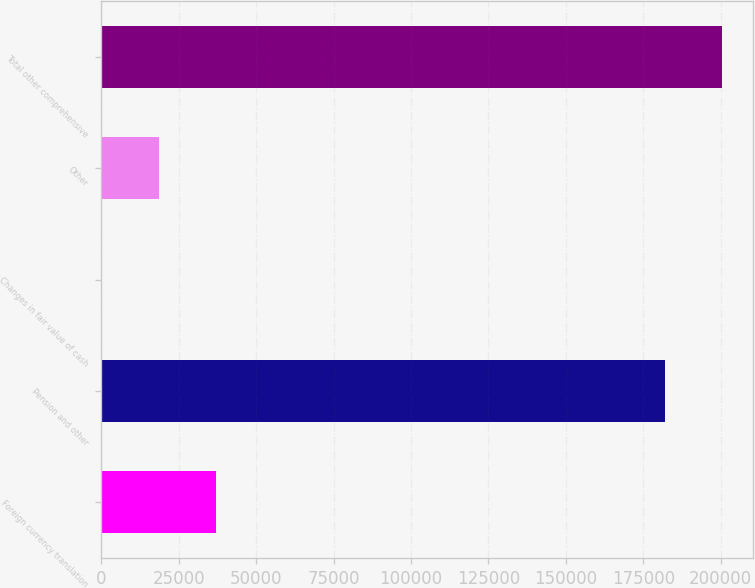Convert chart to OTSL. <chart><loc_0><loc_0><loc_500><loc_500><bar_chart><fcel>Foreign currency translation<fcel>Pension and other<fcel>Changes in fair value of cash<fcel>Other<fcel>Total other comprehensive<nl><fcel>36855.4<fcel>182092<fcel>75<fcel>18465.2<fcel>200482<nl></chart> 